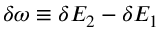Convert formula to latex. <formula><loc_0><loc_0><loc_500><loc_500>\delta \omega \equiv \delta E _ { 2 } - \delta E _ { 1 }</formula> 